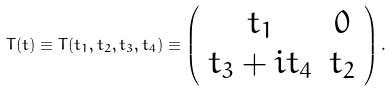<formula> <loc_0><loc_0><loc_500><loc_500>T ( t ) \equiv T ( t _ { 1 } , t _ { 2 } , t _ { 3 } , t _ { 4 } ) \equiv \left ( \begin{array} { c c } t _ { 1 } & 0 \\ t _ { 3 } + i t _ { 4 } & t _ { 2 } \end{array} \right ) .</formula> 